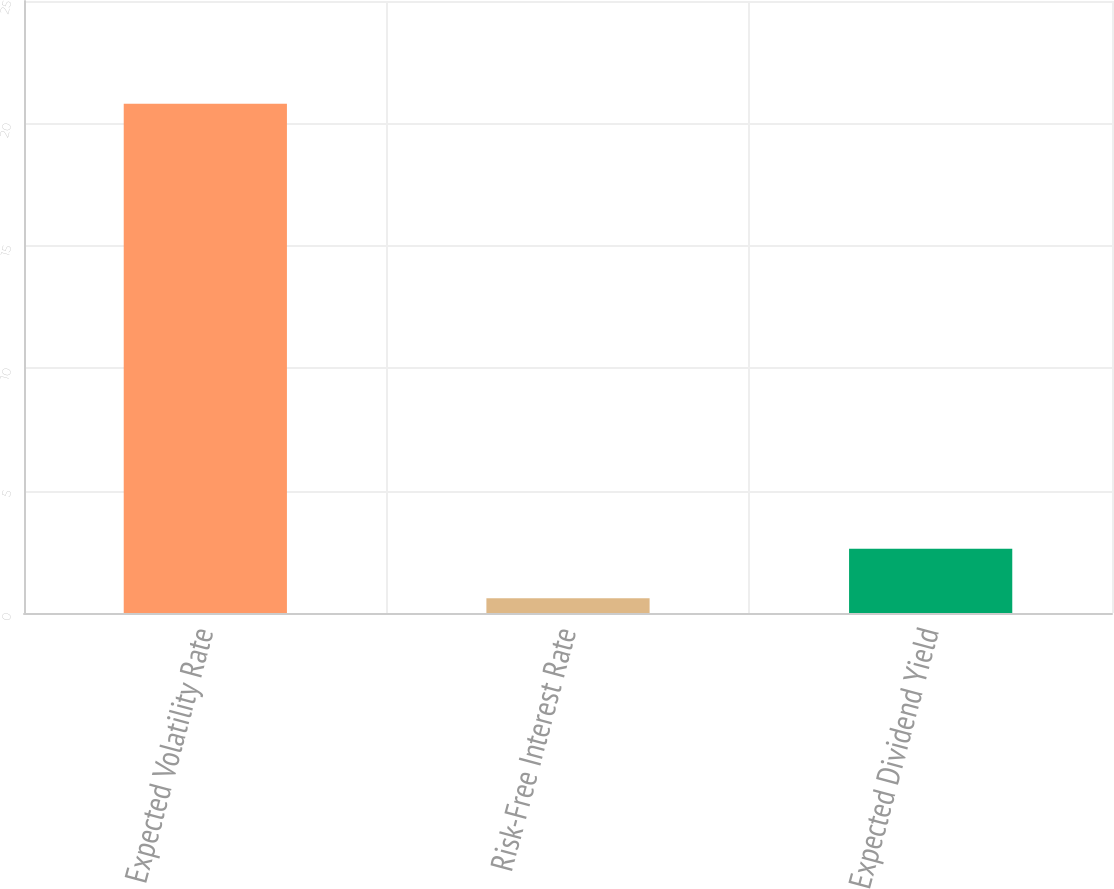Convert chart. <chart><loc_0><loc_0><loc_500><loc_500><bar_chart><fcel>Expected Volatility Rate<fcel>Risk-Free Interest Rate<fcel>Expected Dividend Yield<nl><fcel>20.8<fcel>0.6<fcel>2.62<nl></chart> 